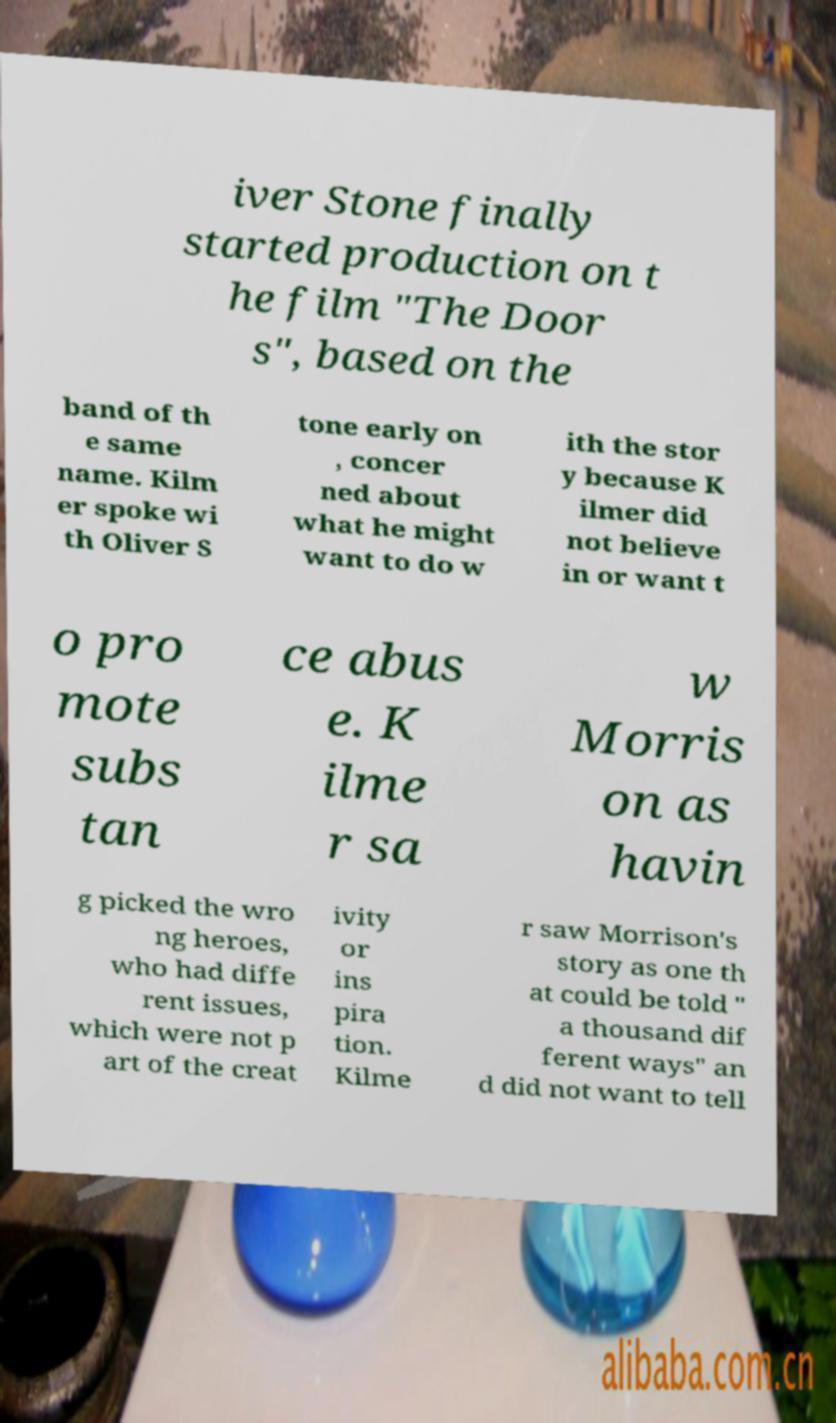Can you read and provide the text displayed in the image?This photo seems to have some interesting text. Can you extract and type it out for me? iver Stone finally started production on t he film "The Door s", based on the band of th e same name. Kilm er spoke wi th Oliver S tone early on , concer ned about what he might want to do w ith the stor y because K ilmer did not believe in or want t o pro mote subs tan ce abus e. K ilme r sa w Morris on as havin g picked the wro ng heroes, who had diffe rent issues, which were not p art of the creat ivity or ins pira tion. Kilme r saw Morrison's story as one th at could be told " a thousand dif ferent ways" an d did not want to tell 